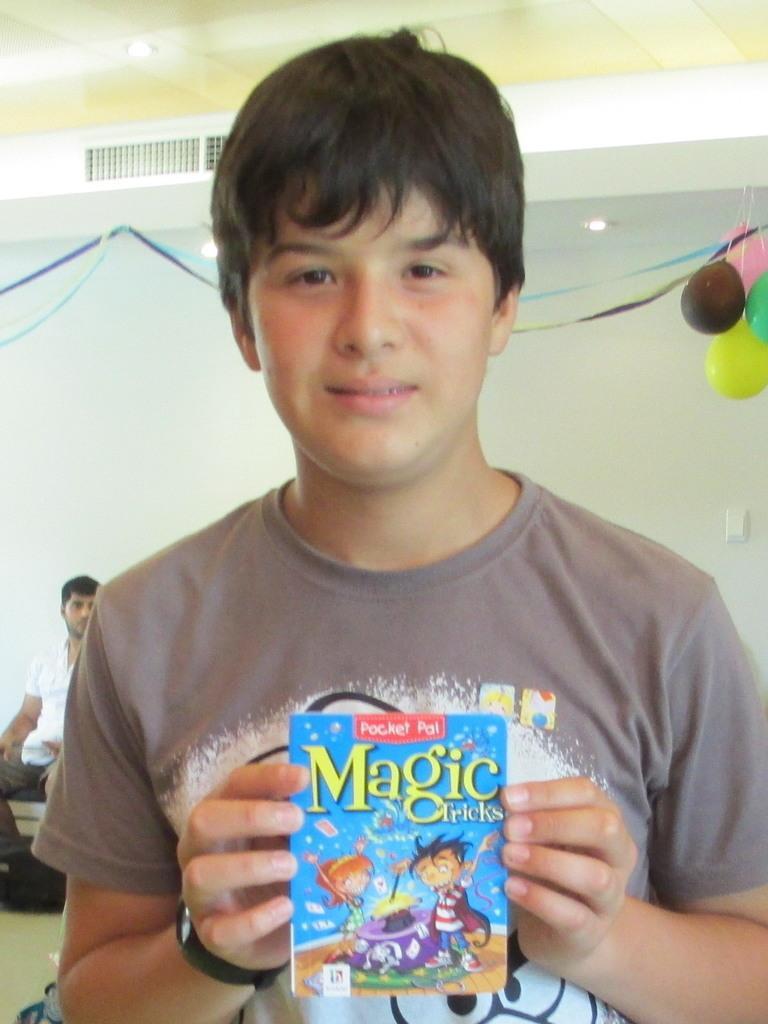Describe this image in one or two sentences. In this picture I can see a man is holding an object in the hand. In the background I can see man is sitting. I can also see balloons, wall, lights on the ceiling. 